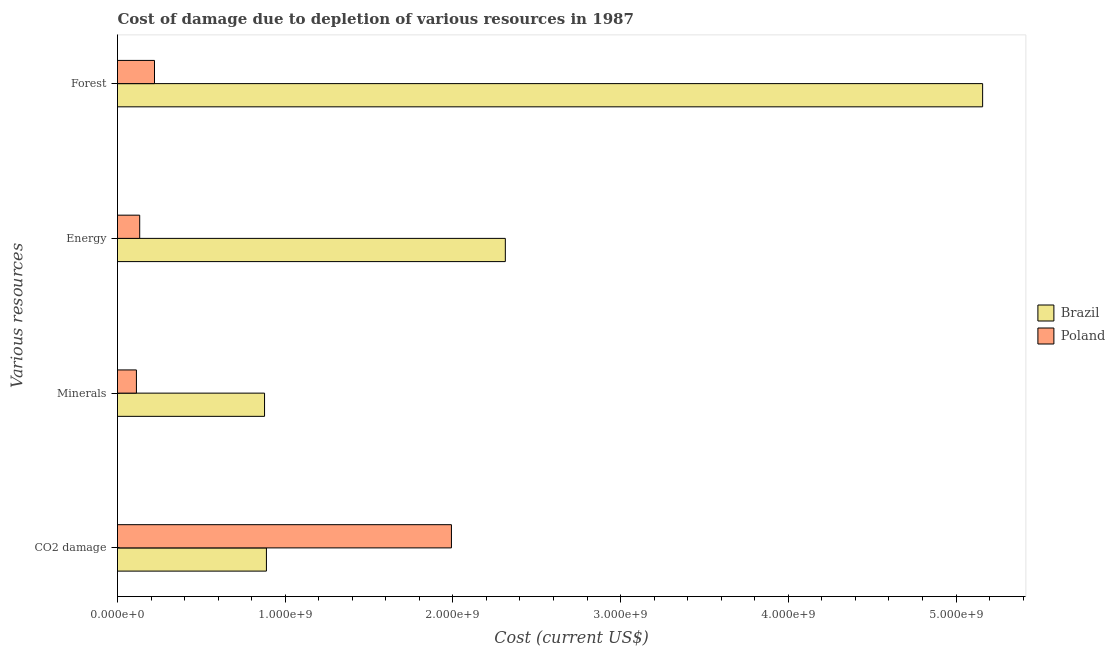How many different coloured bars are there?
Provide a succinct answer. 2. Are the number of bars per tick equal to the number of legend labels?
Offer a very short reply. Yes. Are the number of bars on each tick of the Y-axis equal?
Your response must be concise. Yes. How many bars are there on the 2nd tick from the bottom?
Give a very brief answer. 2. What is the label of the 3rd group of bars from the top?
Ensure brevity in your answer.  Minerals. What is the cost of damage due to depletion of minerals in Brazil?
Your answer should be very brief. 8.77e+08. Across all countries, what is the maximum cost of damage due to depletion of minerals?
Provide a short and direct response. 8.77e+08. Across all countries, what is the minimum cost of damage due to depletion of coal?
Your answer should be compact. 8.88e+08. What is the total cost of damage due to depletion of energy in the graph?
Your answer should be very brief. 2.45e+09. What is the difference between the cost of damage due to depletion of coal in Poland and that in Brazil?
Provide a succinct answer. 1.10e+09. What is the difference between the cost of damage due to depletion of coal in Brazil and the cost of damage due to depletion of minerals in Poland?
Ensure brevity in your answer.  7.75e+08. What is the average cost of damage due to depletion of energy per country?
Your answer should be very brief. 1.22e+09. What is the difference between the cost of damage due to depletion of minerals and cost of damage due to depletion of forests in Poland?
Your response must be concise. -1.08e+08. In how many countries, is the cost of damage due to depletion of forests greater than 4800000000 US$?
Your answer should be compact. 1. What is the ratio of the cost of damage due to depletion of minerals in Brazil to that in Poland?
Keep it short and to the point. 7.77. Is the cost of damage due to depletion of energy in Poland less than that in Brazil?
Offer a terse response. Yes. What is the difference between the highest and the second highest cost of damage due to depletion of minerals?
Offer a terse response. 7.64e+08. What is the difference between the highest and the lowest cost of damage due to depletion of minerals?
Your answer should be compact. 7.64e+08. In how many countries, is the cost of damage due to depletion of forests greater than the average cost of damage due to depletion of forests taken over all countries?
Offer a very short reply. 1. Is the sum of the cost of damage due to depletion of forests in Poland and Brazil greater than the maximum cost of damage due to depletion of coal across all countries?
Make the answer very short. Yes. Is it the case that in every country, the sum of the cost of damage due to depletion of forests and cost of damage due to depletion of energy is greater than the sum of cost of damage due to depletion of minerals and cost of damage due to depletion of coal?
Make the answer very short. No. What does the 2nd bar from the bottom in Energy represents?
Provide a short and direct response. Poland. How many bars are there?
Ensure brevity in your answer.  8. Are all the bars in the graph horizontal?
Keep it short and to the point. Yes. What is the difference between two consecutive major ticks on the X-axis?
Offer a very short reply. 1.00e+09. Are the values on the major ticks of X-axis written in scientific E-notation?
Make the answer very short. Yes. How many legend labels are there?
Your answer should be very brief. 2. What is the title of the graph?
Keep it short and to the point. Cost of damage due to depletion of various resources in 1987 . What is the label or title of the X-axis?
Keep it short and to the point. Cost (current US$). What is the label or title of the Y-axis?
Your response must be concise. Various resources. What is the Cost (current US$) of Brazil in CO2 damage?
Provide a succinct answer. 8.88e+08. What is the Cost (current US$) in Poland in CO2 damage?
Provide a succinct answer. 1.99e+09. What is the Cost (current US$) in Brazil in Minerals?
Ensure brevity in your answer.  8.77e+08. What is the Cost (current US$) of Poland in Minerals?
Your answer should be compact. 1.13e+08. What is the Cost (current US$) in Brazil in Energy?
Your answer should be very brief. 2.31e+09. What is the Cost (current US$) of Poland in Energy?
Give a very brief answer. 1.32e+08. What is the Cost (current US$) of Brazil in Forest?
Offer a terse response. 5.16e+09. What is the Cost (current US$) of Poland in Forest?
Make the answer very short. 2.21e+08. Across all Various resources, what is the maximum Cost (current US$) of Brazil?
Your response must be concise. 5.16e+09. Across all Various resources, what is the maximum Cost (current US$) of Poland?
Your answer should be compact. 1.99e+09. Across all Various resources, what is the minimum Cost (current US$) in Brazil?
Keep it short and to the point. 8.77e+08. Across all Various resources, what is the minimum Cost (current US$) in Poland?
Your answer should be compact. 1.13e+08. What is the total Cost (current US$) in Brazil in the graph?
Give a very brief answer. 9.24e+09. What is the total Cost (current US$) of Poland in the graph?
Give a very brief answer. 2.46e+09. What is the difference between the Cost (current US$) in Brazil in CO2 damage and that in Minerals?
Your answer should be very brief. 1.12e+07. What is the difference between the Cost (current US$) in Poland in CO2 damage and that in Minerals?
Offer a very short reply. 1.88e+09. What is the difference between the Cost (current US$) in Brazil in CO2 damage and that in Energy?
Make the answer very short. -1.42e+09. What is the difference between the Cost (current US$) in Poland in CO2 damage and that in Energy?
Keep it short and to the point. 1.86e+09. What is the difference between the Cost (current US$) of Brazil in CO2 damage and that in Forest?
Keep it short and to the point. -4.27e+09. What is the difference between the Cost (current US$) in Poland in CO2 damage and that in Forest?
Provide a short and direct response. 1.77e+09. What is the difference between the Cost (current US$) of Brazil in Minerals and that in Energy?
Provide a succinct answer. -1.44e+09. What is the difference between the Cost (current US$) in Poland in Minerals and that in Energy?
Your response must be concise. -1.96e+07. What is the difference between the Cost (current US$) of Brazil in Minerals and that in Forest?
Give a very brief answer. -4.28e+09. What is the difference between the Cost (current US$) of Poland in Minerals and that in Forest?
Provide a short and direct response. -1.08e+08. What is the difference between the Cost (current US$) of Brazil in Energy and that in Forest?
Your answer should be compact. -2.85e+09. What is the difference between the Cost (current US$) in Poland in Energy and that in Forest?
Offer a terse response. -8.82e+07. What is the difference between the Cost (current US$) in Brazil in CO2 damage and the Cost (current US$) in Poland in Minerals?
Ensure brevity in your answer.  7.75e+08. What is the difference between the Cost (current US$) of Brazil in CO2 damage and the Cost (current US$) of Poland in Energy?
Provide a short and direct response. 7.56e+08. What is the difference between the Cost (current US$) in Brazil in CO2 damage and the Cost (current US$) in Poland in Forest?
Ensure brevity in your answer.  6.67e+08. What is the difference between the Cost (current US$) of Brazil in Minerals and the Cost (current US$) of Poland in Energy?
Provide a succinct answer. 7.44e+08. What is the difference between the Cost (current US$) in Brazil in Minerals and the Cost (current US$) in Poland in Forest?
Keep it short and to the point. 6.56e+08. What is the difference between the Cost (current US$) in Brazil in Energy and the Cost (current US$) in Poland in Forest?
Give a very brief answer. 2.09e+09. What is the average Cost (current US$) in Brazil per Various resources?
Offer a very short reply. 2.31e+09. What is the average Cost (current US$) in Poland per Various resources?
Your answer should be very brief. 6.14e+08. What is the difference between the Cost (current US$) in Brazil and Cost (current US$) in Poland in CO2 damage?
Give a very brief answer. -1.10e+09. What is the difference between the Cost (current US$) of Brazil and Cost (current US$) of Poland in Minerals?
Ensure brevity in your answer.  7.64e+08. What is the difference between the Cost (current US$) of Brazil and Cost (current US$) of Poland in Energy?
Your answer should be very brief. 2.18e+09. What is the difference between the Cost (current US$) of Brazil and Cost (current US$) of Poland in Forest?
Your answer should be very brief. 4.94e+09. What is the ratio of the Cost (current US$) in Brazil in CO2 damage to that in Minerals?
Provide a succinct answer. 1.01. What is the ratio of the Cost (current US$) of Poland in CO2 damage to that in Minerals?
Keep it short and to the point. 17.65. What is the ratio of the Cost (current US$) of Brazil in CO2 damage to that in Energy?
Offer a terse response. 0.38. What is the ratio of the Cost (current US$) in Poland in CO2 damage to that in Energy?
Your response must be concise. 15.04. What is the ratio of the Cost (current US$) in Brazil in CO2 damage to that in Forest?
Keep it short and to the point. 0.17. What is the ratio of the Cost (current US$) of Poland in CO2 damage to that in Forest?
Provide a succinct answer. 9.03. What is the ratio of the Cost (current US$) in Brazil in Minerals to that in Energy?
Your response must be concise. 0.38. What is the ratio of the Cost (current US$) of Poland in Minerals to that in Energy?
Provide a short and direct response. 0.85. What is the ratio of the Cost (current US$) in Brazil in Minerals to that in Forest?
Your answer should be very brief. 0.17. What is the ratio of the Cost (current US$) in Poland in Minerals to that in Forest?
Make the answer very short. 0.51. What is the ratio of the Cost (current US$) of Brazil in Energy to that in Forest?
Make the answer very short. 0.45. What is the ratio of the Cost (current US$) of Poland in Energy to that in Forest?
Provide a short and direct response. 0.6. What is the difference between the highest and the second highest Cost (current US$) of Brazil?
Make the answer very short. 2.85e+09. What is the difference between the highest and the second highest Cost (current US$) in Poland?
Your answer should be compact. 1.77e+09. What is the difference between the highest and the lowest Cost (current US$) of Brazil?
Keep it short and to the point. 4.28e+09. What is the difference between the highest and the lowest Cost (current US$) in Poland?
Keep it short and to the point. 1.88e+09. 